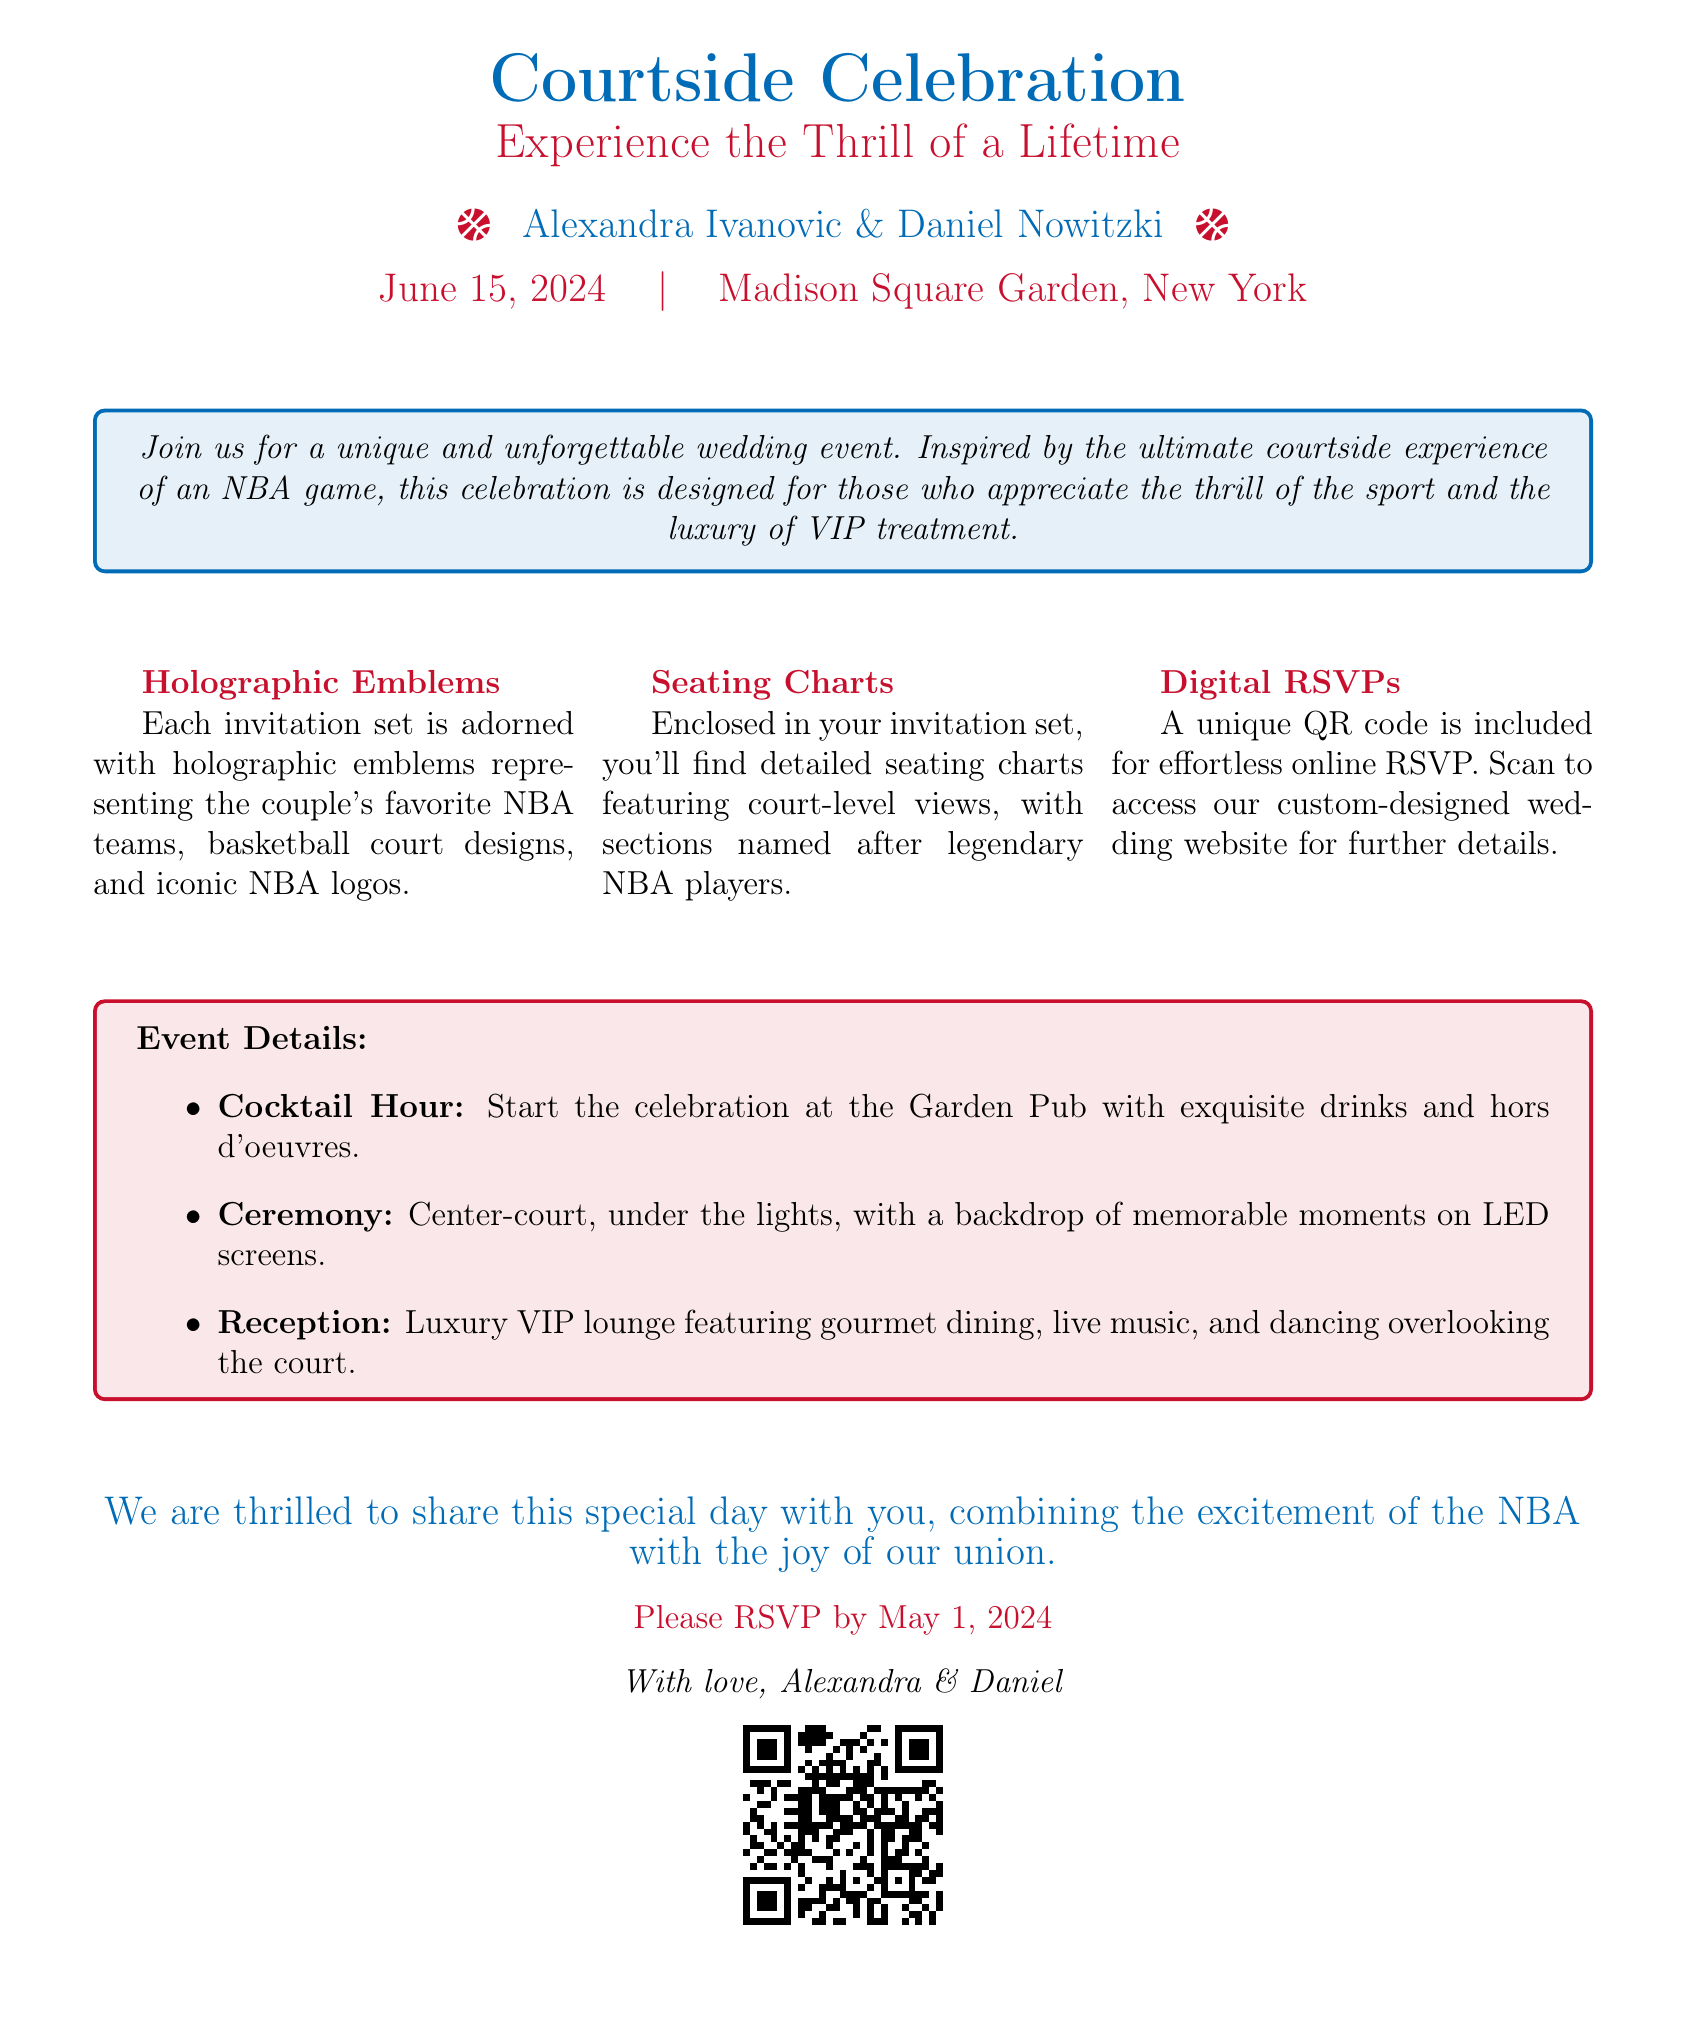what is the name of the couple? The names of the couple are prominently displayed at the top of the invitation.
Answer: Alexandra Ivanovic & Daniel Nowitzki when is the wedding date? The wedding date is stated clearly beneath the couple's names.
Answer: June 15, 2024 where is the wedding ceremony taking place? The location of the ceremony is mentioned in the event details section.
Answer: Madison Square Garden, New York what is included in the invitation set? The invitation mentions three specific items included in the set.
Answer: Holographic emblems, Seating charts, Digital RSVPs what is the RSVP deadline? The RSVP deadline is specified towards the end of the document.
Answer: May 1, 2024 what unique feature does the invitation set have for RSVPs? The document specifies a feature that simplifies the RSVP process.
Answer: QR code what type of event is emphasized in the invitation? The overall theme of the invitation draws on a particular sporting event experience.
Answer: NBA game what setting will the ceremony occur? The document describes the specific setting for the wedding ceremony.
Answer: Center-court what type of reception will guests have? The details about the reception emphasize its luxurious aspect.
Answer: Luxury VIP lounge 